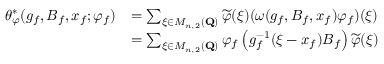Convert formula to latex. <formula><loc_0><loc_0><loc_500><loc_500>\begin{array} { r l } { \theta _ { \varphi } ^ { * } ( g _ { f } , B _ { f } , x _ { f } ; \varphi _ { f } ) } & { = \sum _ { \xi \in M _ { n , 2 } ( Q ) } \widetilde { \varphi } ( \xi ) ( \omega ( g _ { f } , B _ { f } , x _ { f } ) \varphi _ { f } ) ( \xi ) } \\ & { = \sum _ { \xi \in M _ { n , 2 } ( Q ) } \varphi _ { f } \left ( g _ { f } ^ { - 1 } ( \xi - x _ { f } ) B _ { f } \right ) \widetilde { \varphi } ( \xi ) } \end{array}</formula> 